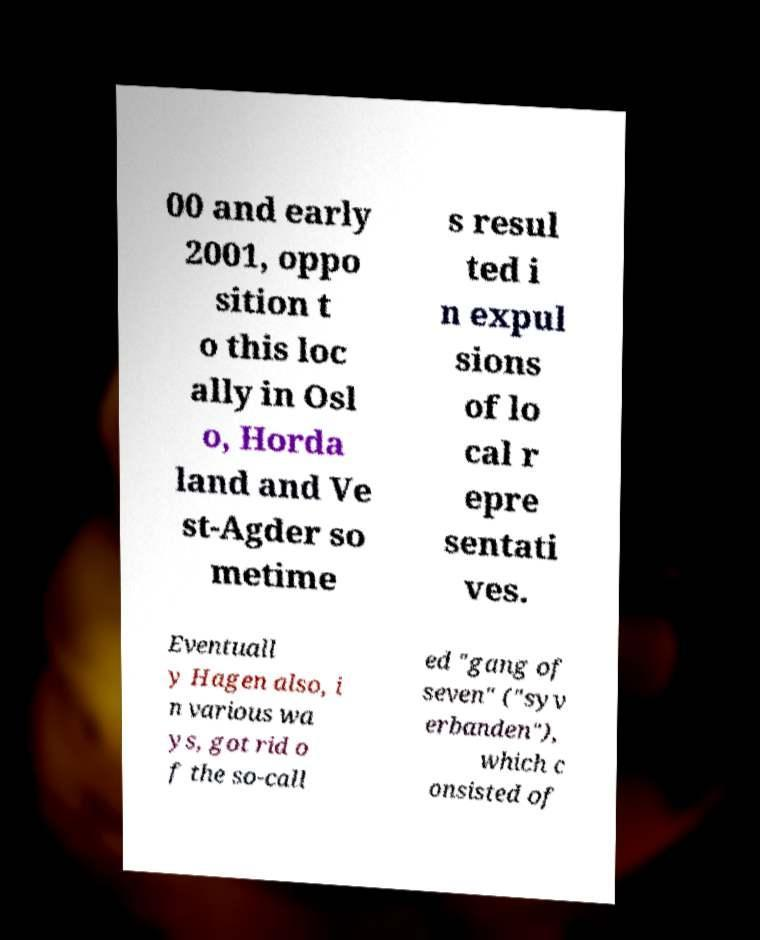Can you read and provide the text displayed in the image?This photo seems to have some interesting text. Can you extract and type it out for me? 00 and early 2001, oppo sition t o this loc ally in Osl o, Horda land and Ve st-Agder so metime s resul ted i n expul sions of lo cal r epre sentati ves. Eventuall y Hagen also, i n various wa ys, got rid o f the so-call ed "gang of seven" ("syv erbanden"), which c onsisted of 